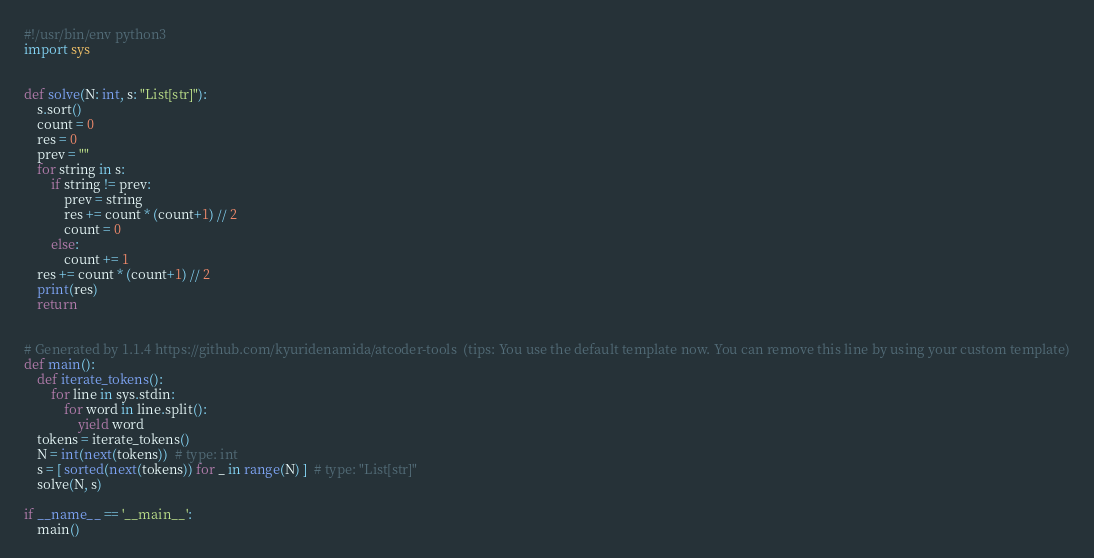<code> <loc_0><loc_0><loc_500><loc_500><_Python_>#!/usr/bin/env python3
import sys


def solve(N: int, s: "List[str]"):
    s.sort()
    count = 0
    res = 0
    prev = ""
    for string in s:
        if string != prev:
            prev = string
            res += count * (count+1) // 2
            count = 0
        else:
            count += 1
    res += count * (count+1) // 2    
    print(res)
    return


# Generated by 1.1.4 https://github.com/kyuridenamida/atcoder-tools  (tips: You use the default template now. You can remove this line by using your custom template)
def main():
    def iterate_tokens():
        for line in sys.stdin:
            for word in line.split():
                yield word
    tokens = iterate_tokens()
    N = int(next(tokens))  # type: int
    s = [ sorted(next(tokens)) for _ in range(N) ]  # type: "List[str]"
    solve(N, s)

if __name__ == '__main__':
    main()
</code> 